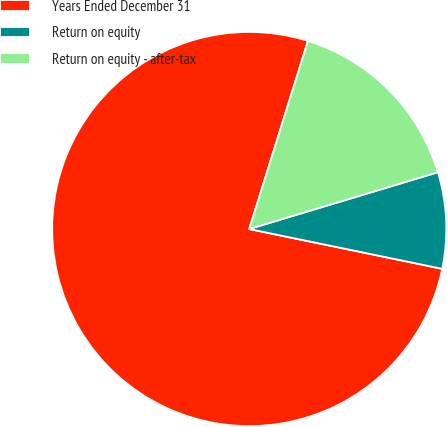<chart> <loc_0><loc_0><loc_500><loc_500><pie_chart><fcel>Years Ended December 31<fcel>Return on equity<fcel>Return on equity - after-tax<nl><fcel>76.58%<fcel>7.89%<fcel>15.53%<nl></chart> 